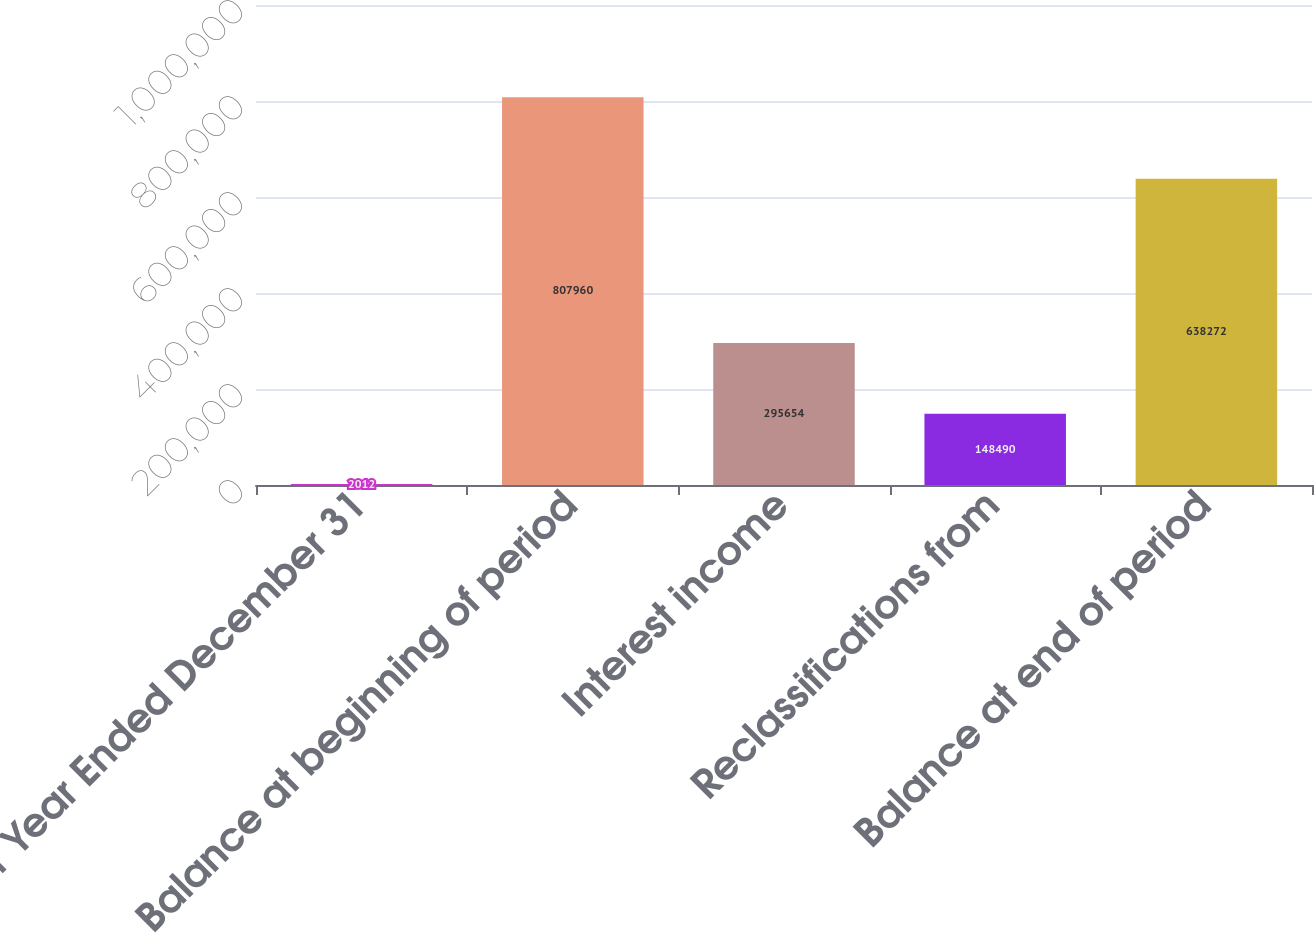<chart> <loc_0><loc_0><loc_500><loc_500><bar_chart><fcel>For Year Ended December 31<fcel>Balance at beginning of period<fcel>Interest income<fcel>Reclassifications from<fcel>Balance at end of period<nl><fcel>2012<fcel>807960<fcel>295654<fcel>148490<fcel>638272<nl></chart> 